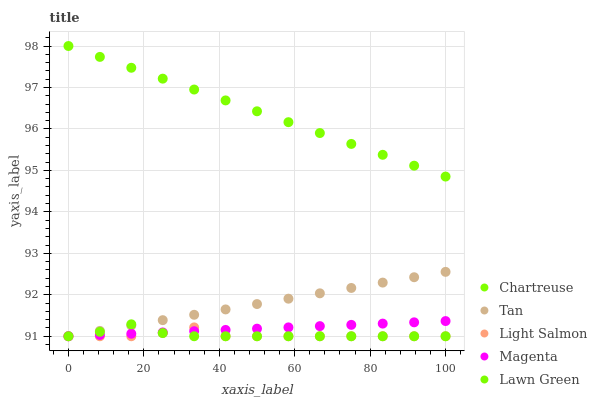Does Light Salmon have the minimum area under the curve?
Answer yes or no. Yes. Does Chartreuse have the maximum area under the curve?
Answer yes or no. Yes. Does Tan have the minimum area under the curve?
Answer yes or no. No. Does Tan have the maximum area under the curve?
Answer yes or no. No. Is Chartreuse the smoothest?
Answer yes or no. Yes. Is Light Salmon the roughest?
Answer yes or no. Yes. Is Tan the smoothest?
Answer yes or no. No. Is Tan the roughest?
Answer yes or no. No. Does Lawn Green have the lowest value?
Answer yes or no. Yes. Does Chartreuse have the lowest value?
Answer yes or no. No. Does Chartreuse have the highest value?
Answer yes or no. Yes. Does Tan have the highest value?
Answer yes or no. No. Is Lawn Green less than Chartreuse?
Answer yes or no. Yes. Is Chartreuse greater than Magenta?
Answer yes or no. Yes. Does Magenta intersect Lawn Green?
Answer yes or no. Yes. Is Magenta less than Lawn Green?
Answer yes or no. No. Is Magenta greater than Lawn Green?
Answer yes or no. No. Does Lawn Green intersect Chartreuse?
Answer yes or no. No. 